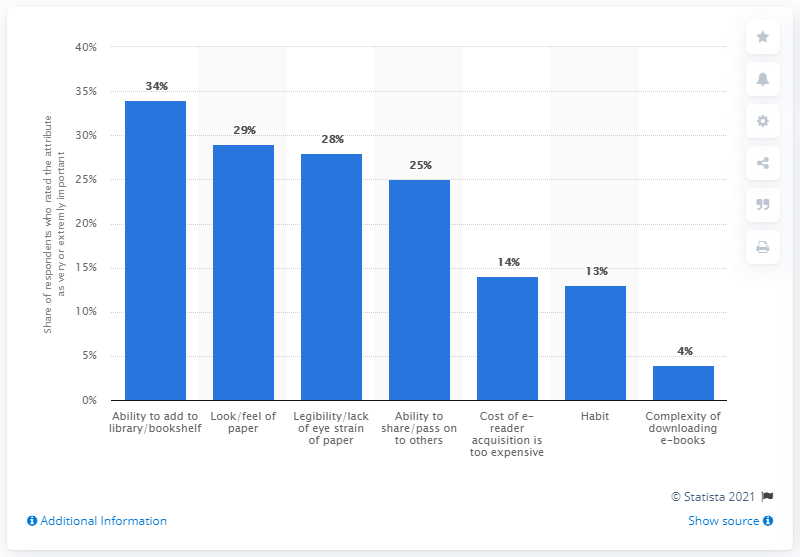Identify some key points in this picture. Nearly 28% of respondents rated the legibility of the text and lack of eye strain as very or extremely important. 